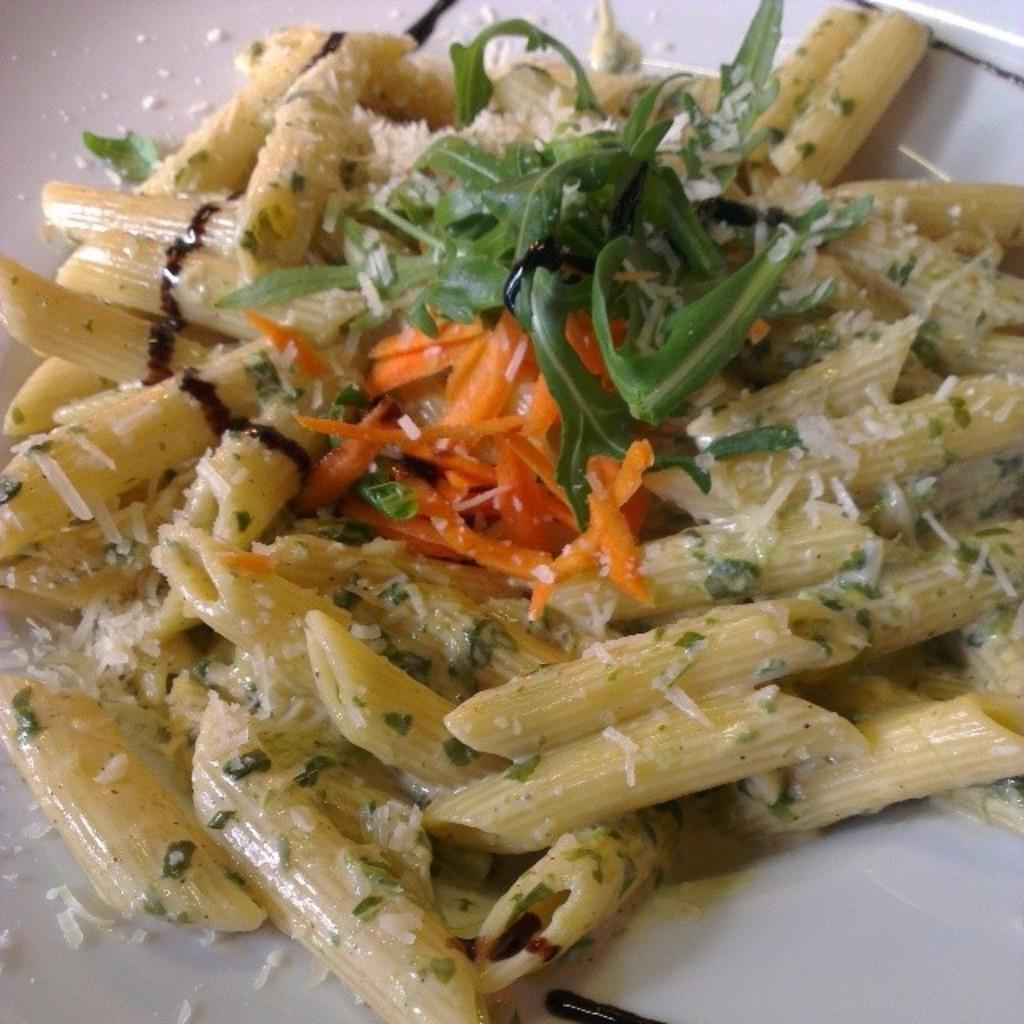What is the main subject of the image? The main subject of the image is food. Can you describe the surface on which the food is placed? The food is on a white surface. How does the wind affect the food on the stage in the image? There is no wind, stage, or any indication of a performance in the image; it only features food on a white surface. 